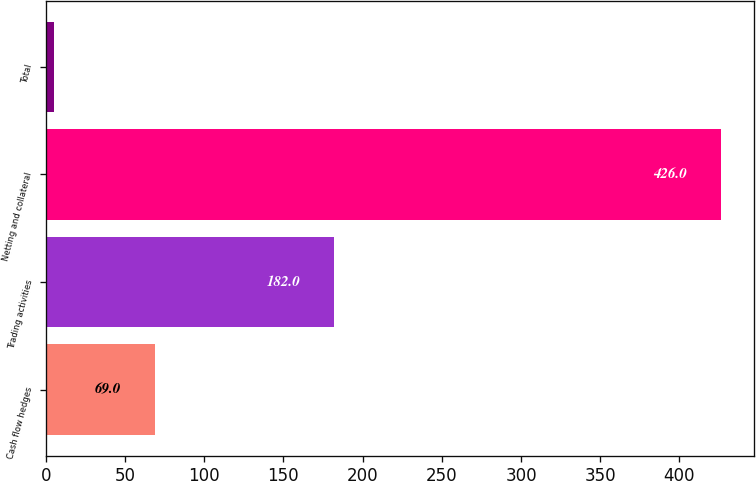<chart> <loc_0><loc_0><loc_500><loc_500><bar_chart><fcel>Cash flow hedges<fcel>Trading activities<fcel>Netting and collateral<fcel>Total<nl><fcel>69<fcel>182<fcel>426<fcel>5<nl></chart> 